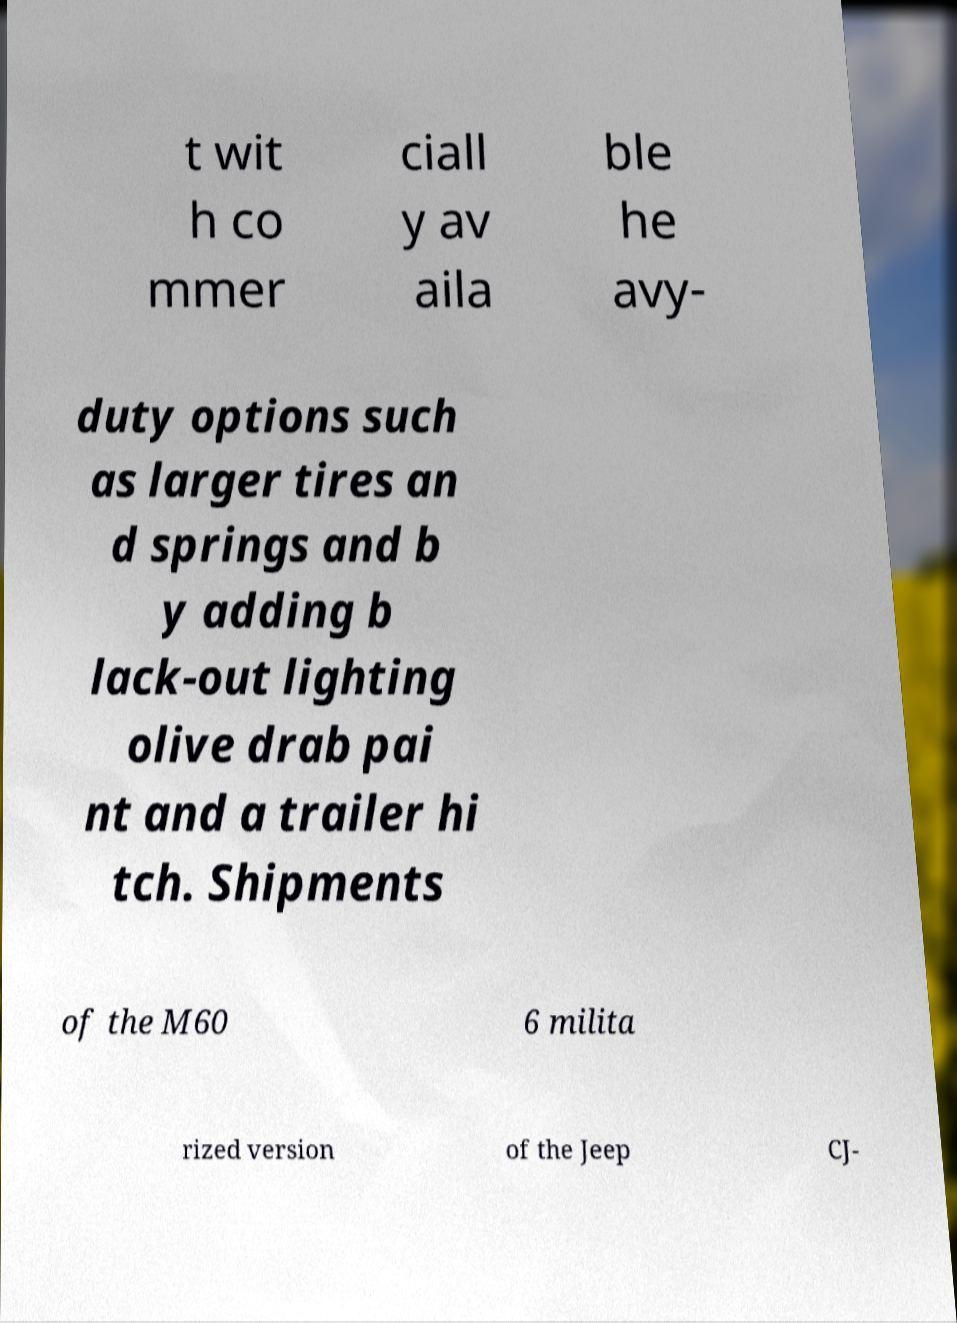Could you extract and type out the text from this image? t wit h co mmer ciall y av aila ble he avy- duty options such as larger tires an d springs and b y adding b lack-out lighting olive drab pai nt and a trailer hi tch. Shipments of the M60 6 milita rized version of the Jeep CJ- 